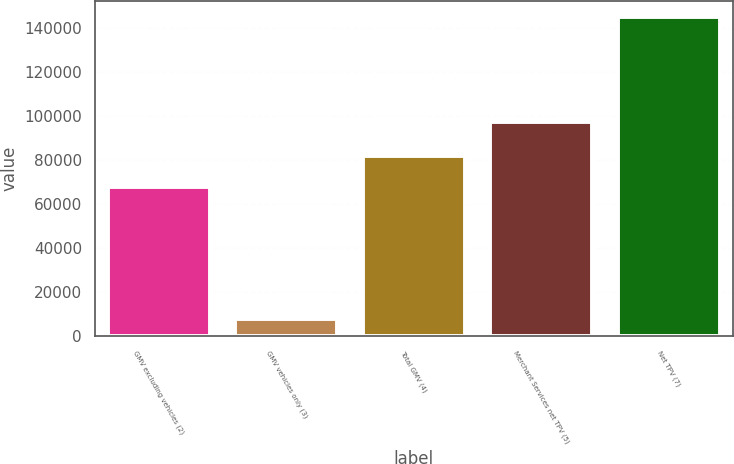Convert chart to OTSL. <chart><loc_0><loc_0><loc_500><loc_500><bar_chart><fcel>GMV excluding vehicles (2)<fcel>GMV vehicles only (3)<fcel>Total GMV (4)<fcel>Merchant Services net TPV (5)<fcel>Net TPV (7)<nl><fcel>67763<fcel>7613<fcel>81495.4<fcel>97277<fcel>144937<nl></chart> 